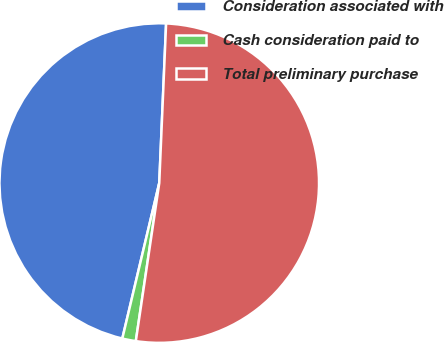<chart> <loc_0><loc_0><loc_500><loc_500><pie_chart><fcel>Consideration associated with<fcel>Cash consideration paid to<fcel>Total preliminary purchase<nl><fcel>46.97%<fcel>1.37%<fcel>51.66%<nl></chart> 